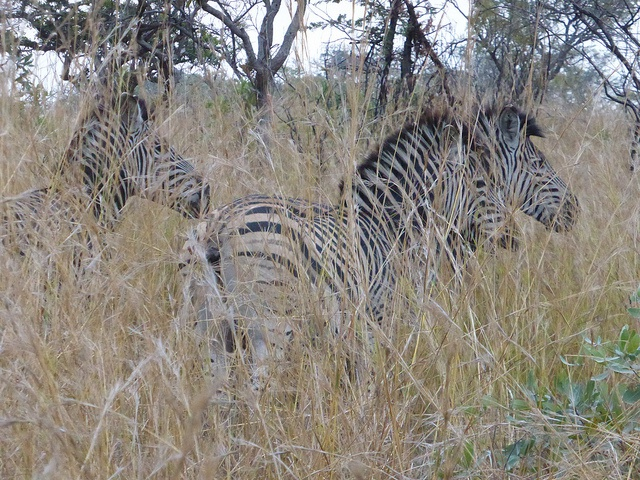Describe the objects in this image and their specific colors. I can see zebra in darkgray and gray tones, zebra in darkgray and gray tones, and zebra in darkgray, gray, and black tones in this image. 